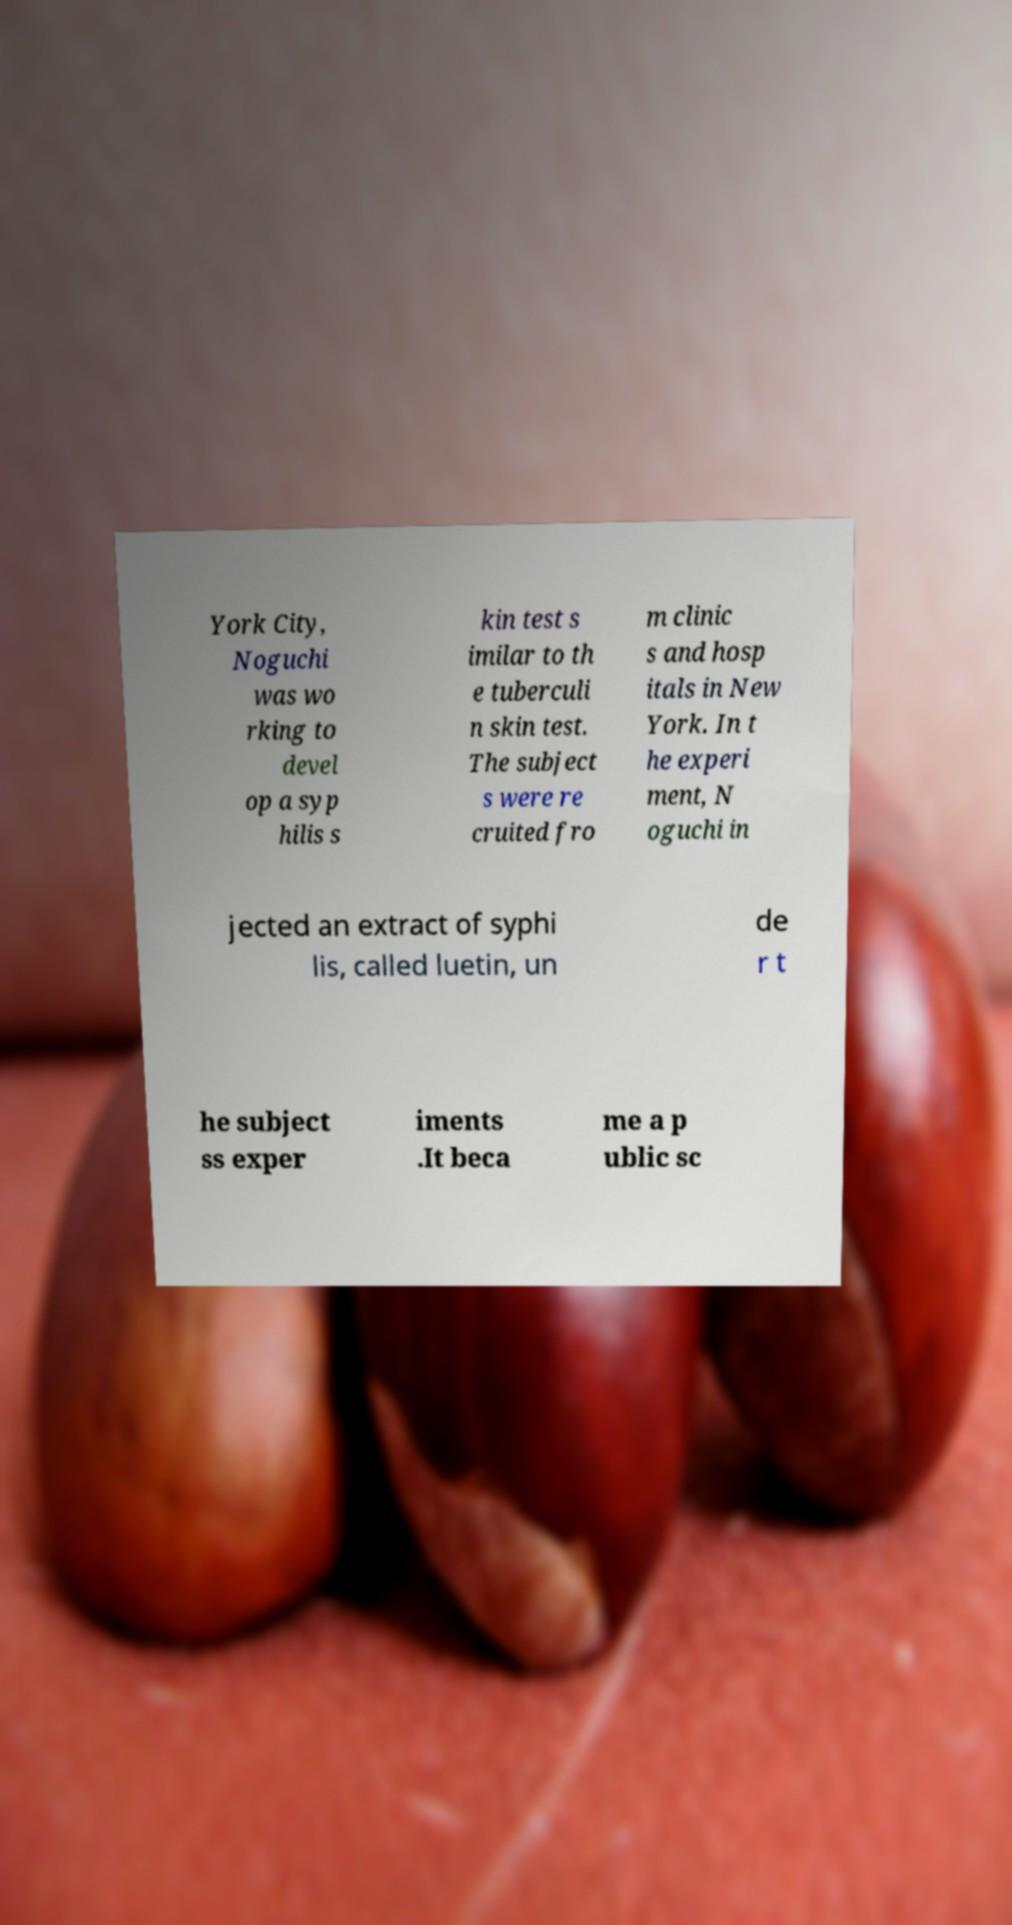There's text embedded in this image that I need extracted. Can you transcribe it verbatim? York City, Noguchi was wo rking to devel op a syp hilis s kin test s imilar to th e tuberculi n skin test. The subject s were re cruited fro m clinic s and hosp itals in New York. In t he experi ment, N oguchi in jected an extract of syphi lis, called luetin, un de r t he subject ss exper iments .It beca me a p ublic sc 